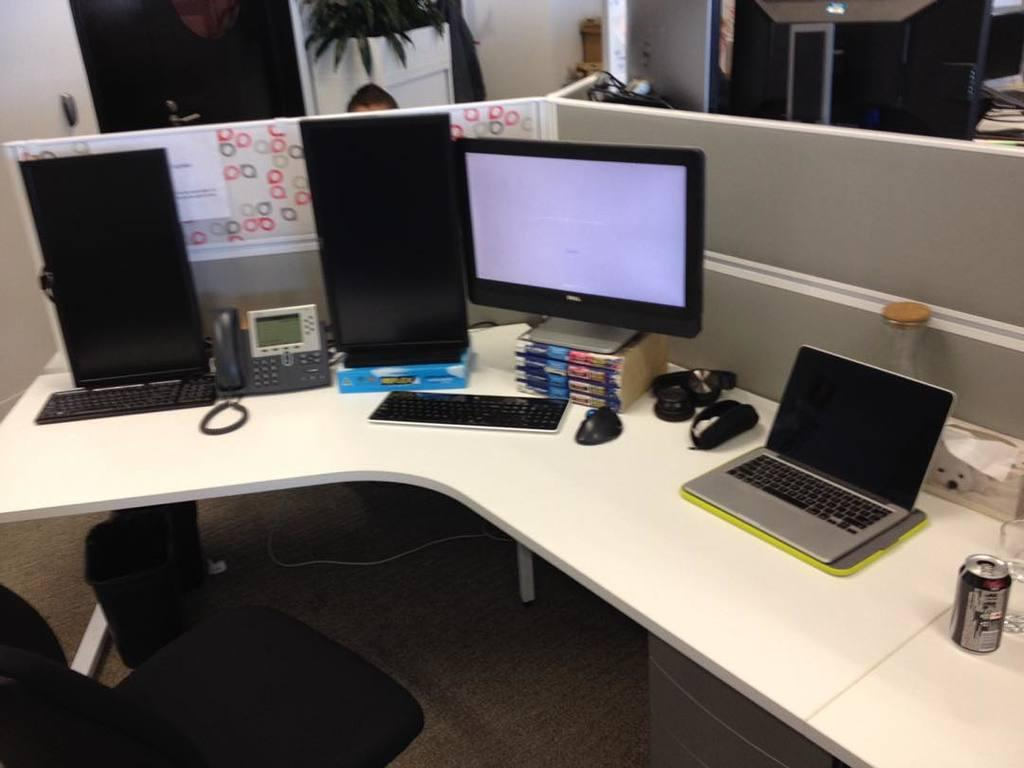What electronic devices are present on the desk table in the image? There is a computer and a laptop on the desk table in the image. What is the color of the desk table? The desk table is white in color. What type of chair is in front of the desk table? There is a black chair in front of the desk table. What is the color of the wall behind the desk table? The wall behind the desk table is white. How many computers are visible on the desk table? There are additional computers on the desk table, so there are at least three computers visible. How does the computer act when it is turned on in the image? The image does not show the computer being turned on, so we cannot determine how it acts when it is turned on. Can you tell me if the person sitting on the chair is crying in the image? There is no person visible in the image, so we cannot determine if anyone is crying. 